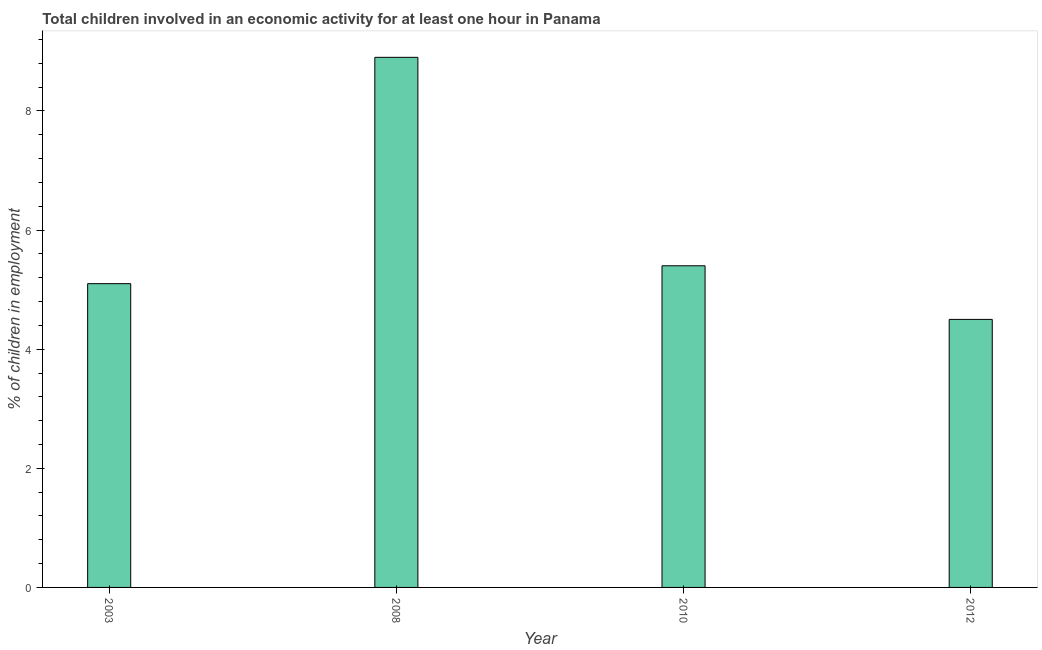Does the graph contain any zero values?
Your answer should be compact. No. What is the title of the graph?
Provide a succinct answer. Total children involved in an economic activity for at least one hour in Panama. What is the label or title of the Y-axis?
Your answer should be very brief. % of children in employment. What is the percentage of children in employment in 2010?
Make the answer very short. 5.4. Across all years, what is the maximum percentage of children in employment?
Your response must be concise. 8.9. Across all years, what is the minimum percentage of children in employment?
Provide a short and direct response. 4.5. What is the sum of the percentage of children in employment?
Ensure brevity in your answer.  23.9. What is the average percentage of children in employment per year?
Your answer should be very brief. 5.97. What is the median percentage of children in employment?
Ensure brevity in your answer.  5.25. In how many years, is the percentage of children in employment greater than 8 %?
Your response must be concise. 1. What is the ratio of the percentage of children in employment in 2003 to that in 2010?
Provide a succinct answer. 0.94. Is the difference between the percentage of children in employment in 2003 and 2008 greater than the difference between any two years?
Keep it short and to the point. No. Is the sum of the percentage of children in employment in 2008 and 2012 greater than the maximum percentage of children in employment across all years?
Make the answer very short. Yes. Are all the bars in the graph horizontal?
Offer a terse response. No. What is the % of children in employment of 2012?
Provide a short and direct response. 4.5. What is the difference between the % of children in employment in 2003 and 2008?
Make the answer very short. -3.8. What is the difference between the % of children in employment in 2003 and 2012?
Your response must be concise. 0.6. What is the difference between the % of children in employment in 2008 and 2010?
Ensure brevity in your answer.  3.5. What is the difference between the % of children in employment in 2008 and 2012?
Your answer should be compact. 4.4. What is the ratio of the % of children in employment in 2003 to that in 2008?
Your answer should be compact. 0.57. What is the ratio of the % of children in employment in 2003 to that in 2010?
Your response must be concise. 0.94. What is the ratio of the % of children in employment in 2003 to that in 2012?
Give a very brief answer. 1.13. What is the ratio of the % of children in employment in 2008 to that in 2010?
Your response must be concise. 1.65. What is the ratio of the % of children in employment in 2008 to that in 2012?
Your response must be concise. 1.98. What is the ratio of the % of children in employment in 2010 to that in 2012?
Your answer should be compact. 1.2. 